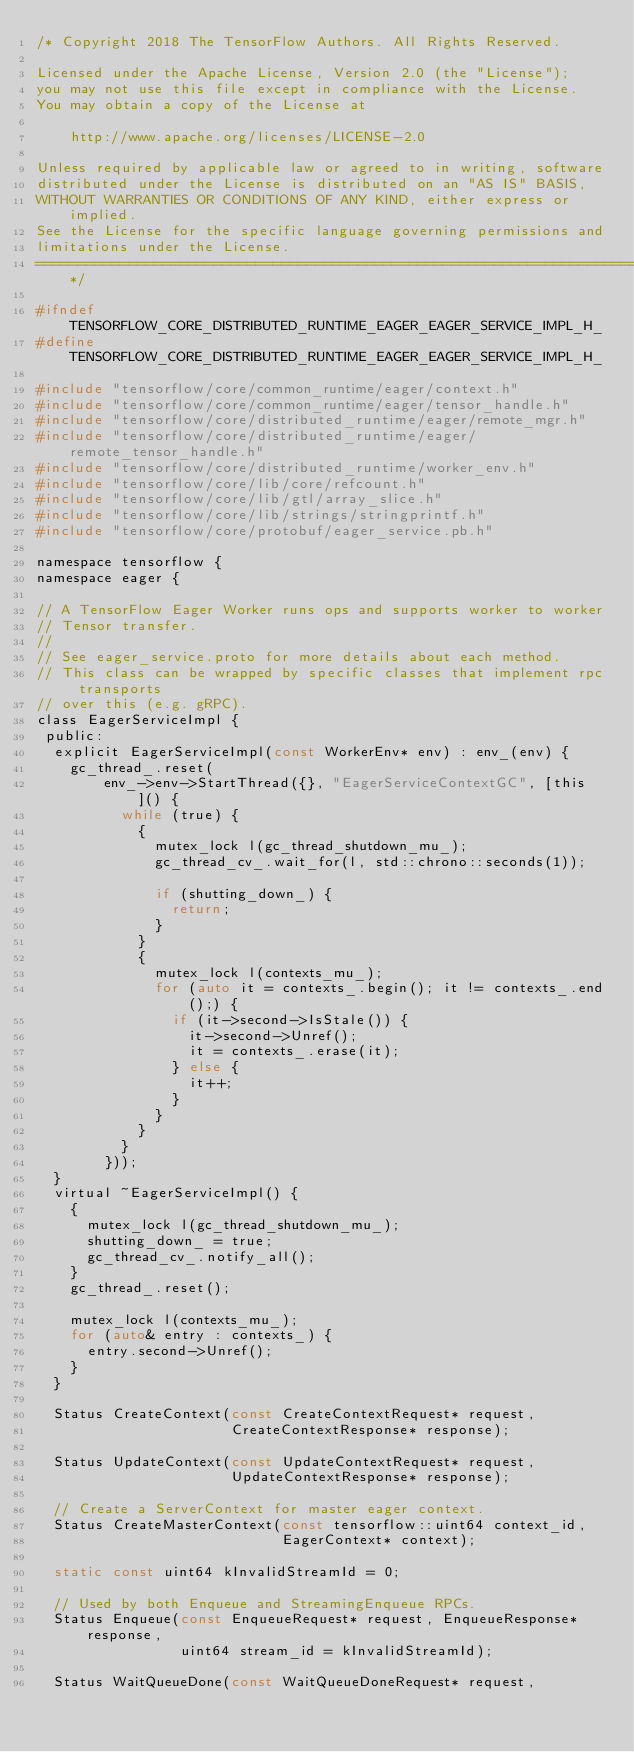Convert code to text. <code><loc_0><loc_0><loc_500><loc_500><_C_>/* Copyright 2018 The TensorFlow Authors. All Rights Reserved.

Licensed under the Apache License, Version 2.0 (the "License");
you may not use this file except in compliance with the License.
You may obtain a copy of the License at

    http://www.apache.org/licenses/LICENSE-2.0

Unless required by applicable law or agreed to in writing, software
distributed under the License is distributed on an "AS IS" BASIS,
WITHOUT WARRANTIES OR CONDITIONS OF ANY KIND, either express or implied.
See the License for the specific language governing permissions and
limitations under the License.
==============================================================================*/

#ifndef TENSORFLOW_CORE_DISTRIBUTED_RUNTIME_EAGER_EAGER_SERVICE_IMPL_H_
#define TENSORFLOW_CORE_DISTRIBUTED_RUNTIME_EAGER_EAGER_SERVICE_IMPL_H_

#include "tensorflow/core/common_runtime/eager/context.h"
#include "tensorflow/core/common_runtime/eager/tensor_handle.h"
#include "tensorflow/core/distributed_runtime/eager/remote_mgr.h"
#include "tensorflow/core/distributed_runtime/eager/remote_tensor_handle.h"
#include "tensorflow/core/distributed_runtime/worker_env.h"
#include "tensorflow/core/lib/core/refcount.h"
#include "tensorflow/core/lib/gtl/array_slice.h"
#include "tensorflow/core/lib/strings/stringprintf.h"
#include "tensorflow/core/protobuf/eager_service.pb.h"

namespace tensorflow {
namespace eager {

// A TensorFlow Eager Worker runs ops and supports worker to worker
// Tensor transfer.
//
// See eager_service.proto for more details about each method.
// This class can be wrapped by specific classes that implement rpc transports
// over this (e.g. gRPC).
class EagerServiceImpl {
 public:
  explicit EagerServiceImpl(const WorkerEnv* env) : env_(env) {
    gc_thread_.reset(
        env_->env->StartThread({}, "EagerServiceContextGC", [this]() {
          while (true) {
            {
              mutex_lock l(gc_thread_shutdown_mu_);
              gc_thread_cv_.wait_for(l, std::chrono::seconds(1));

              if (shutting_down_) {
                return;
              }
            }
            {
              mutex_lock l(contexts_mu_);
              for (auto it = contexts_.begin(); it != contexts_.end();) {
                if (it->second->IsStale()) {
                  it->second->Unref();
                  it = contexts_.erase(it);
                } else {
                  it++;
                }
              }
            }
          }
        }));
  }
  virtual ~EagerServiceImpl() {
    {
      mutex_lock l(gc_thread_shutdown_mu_);
      shutting_down_ = true;
      gc_thread_cv_.notify_all();
    }
    gc_thread_.reset();

    mutex_lock l(contexts_mu_);
    for (auto& entry : contexts_) {
      entry.second->Unref();
    }
  }

  Status CreateContext(const CreateContextRequest* request,
                       CreateContextResponse* response);

  Status UpdateContext(const UpdateContextRequest* request,
                       UpdateContextResponse* response);

  // Create a ServerContext for master eager context.
  Status CreateMasterContext(const tensorflow::uint64 context_id,
                             EagerContext* context);

  static const uint64 kInvalidStreamId = 0;

  // Used by both Enqueue and StreamingEnqueue RPCs.
  Status Enqueue(const EnqueueRequest* request, EnqueueResponse* response,
                 uint64 stream_id = kInvalidStreamId);

  Status WaitQueueDone(const WaitQueueDoneRequest* request,</code> 